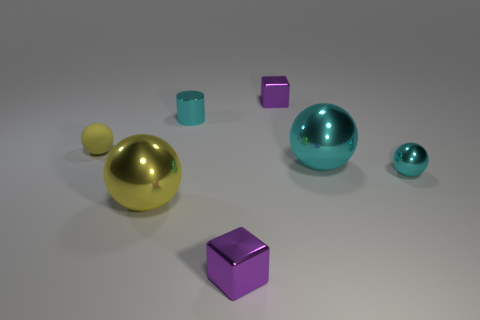Add 1 tiny blue objects. How many objects exist? 8 Subtract all cylinders. How many objects are left? 6 Subtract all rubber cubes. Subtract all yellow spheres. How many objects are left? 5 Add 1 small yellow spheres. How many small yellow spheres are left? 2 Add 6 tiny cyan balls. How many tiny cyan balls exist? 7 Subtract 1 cyan balls. How many objects are left? 6 